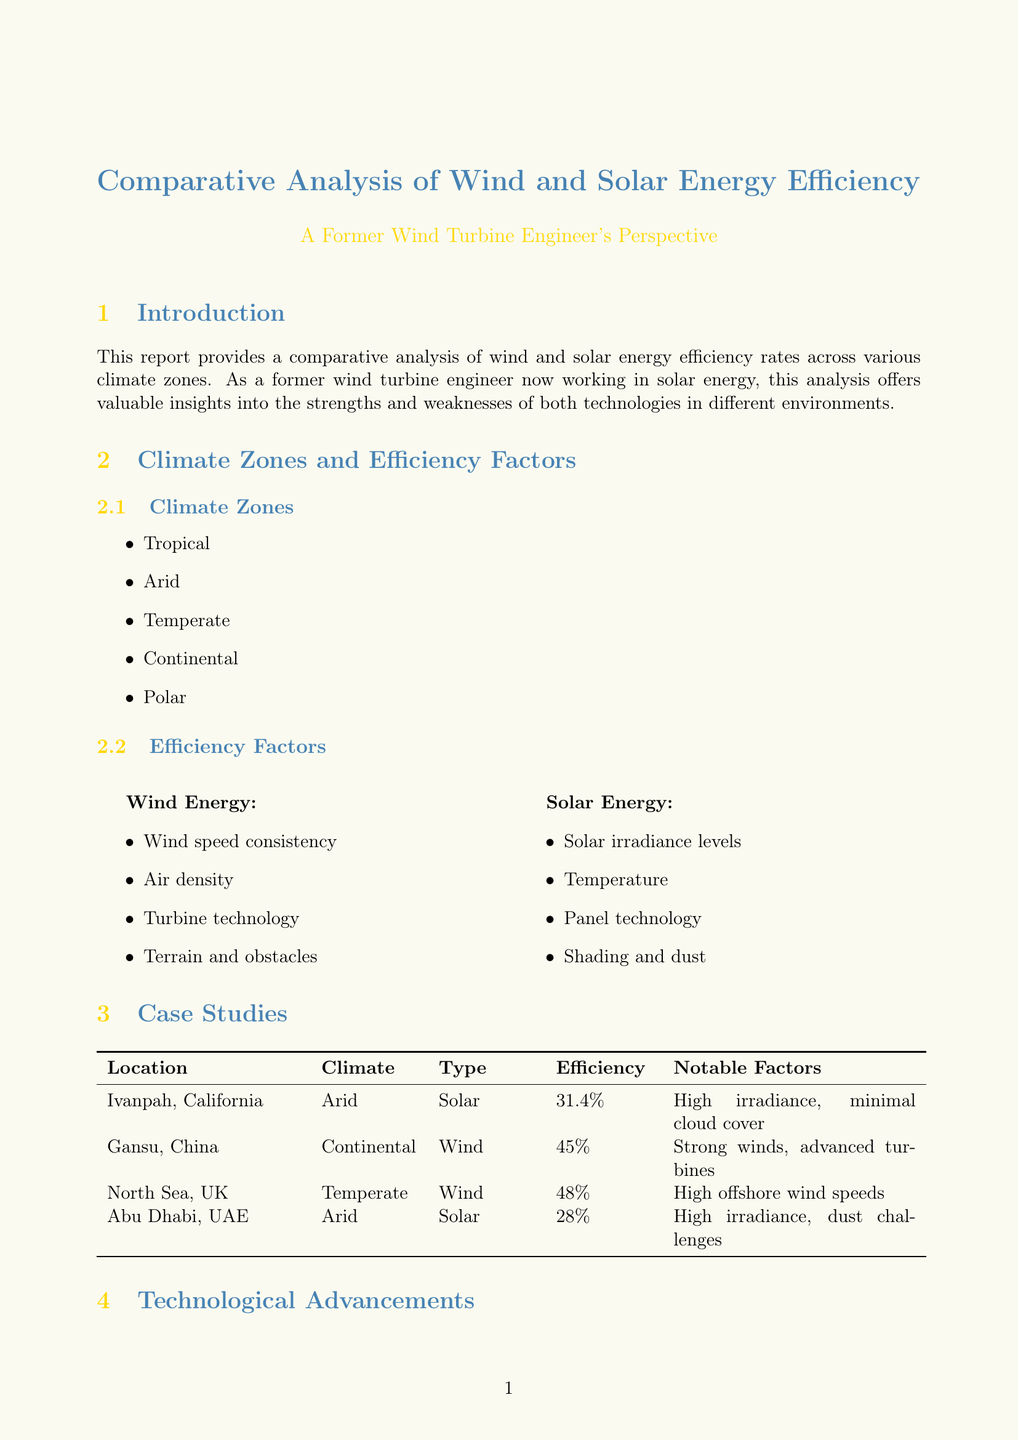What is the main topic of the report? The report provides a comparative analysis of energy efficiency rates for wind and solar energy across various climate zones.
Answer: Comparative analysis of wind and solar energy efficiency rates across climate zones What is the efficiency rate of the Ivanpah Solar Electric Generating System? The Ivanpah Solar Electric Generating System in the Mojave Desert has an efficiency rate of 31.4%.
Answer: 31.4% Which climate zone has high efficiency for solar energy? In the tropical zone, solar energy has high efficiency due to consistent solar irradiance.
Answer: Tropical What notable factor contributes to the efficiency of the Gansu Wind Farm? The Gansu Wind Farm has strong and consistent wind patterns which contribute to its efficiency rate.
Answer: Strong and consistent wind patterns What are the two types of energy discussed in the document? The report analyzes efficiency rates of both wind and solar energy technologies.
Answer: Wind and Solar What is a key finding regarding technological advancements? Technological advancements continue to improve efficiency for both wind and solar energy technologies.
Answer: Technological advancements improve efficiency Which case study location experiences challenges with dust accumulation? The Noor Abu Dhabi Solar Plant experiences challenges with dust accumulation impacting its efficiency.
Answer: Noor Abu Dhabi Solar Plant What future outlook is mentioned for solar energy? Increased adoption of floating solar farms is mentioned as a future outlook for solar energy.
Answer: Increased adoption of floating solar farms 